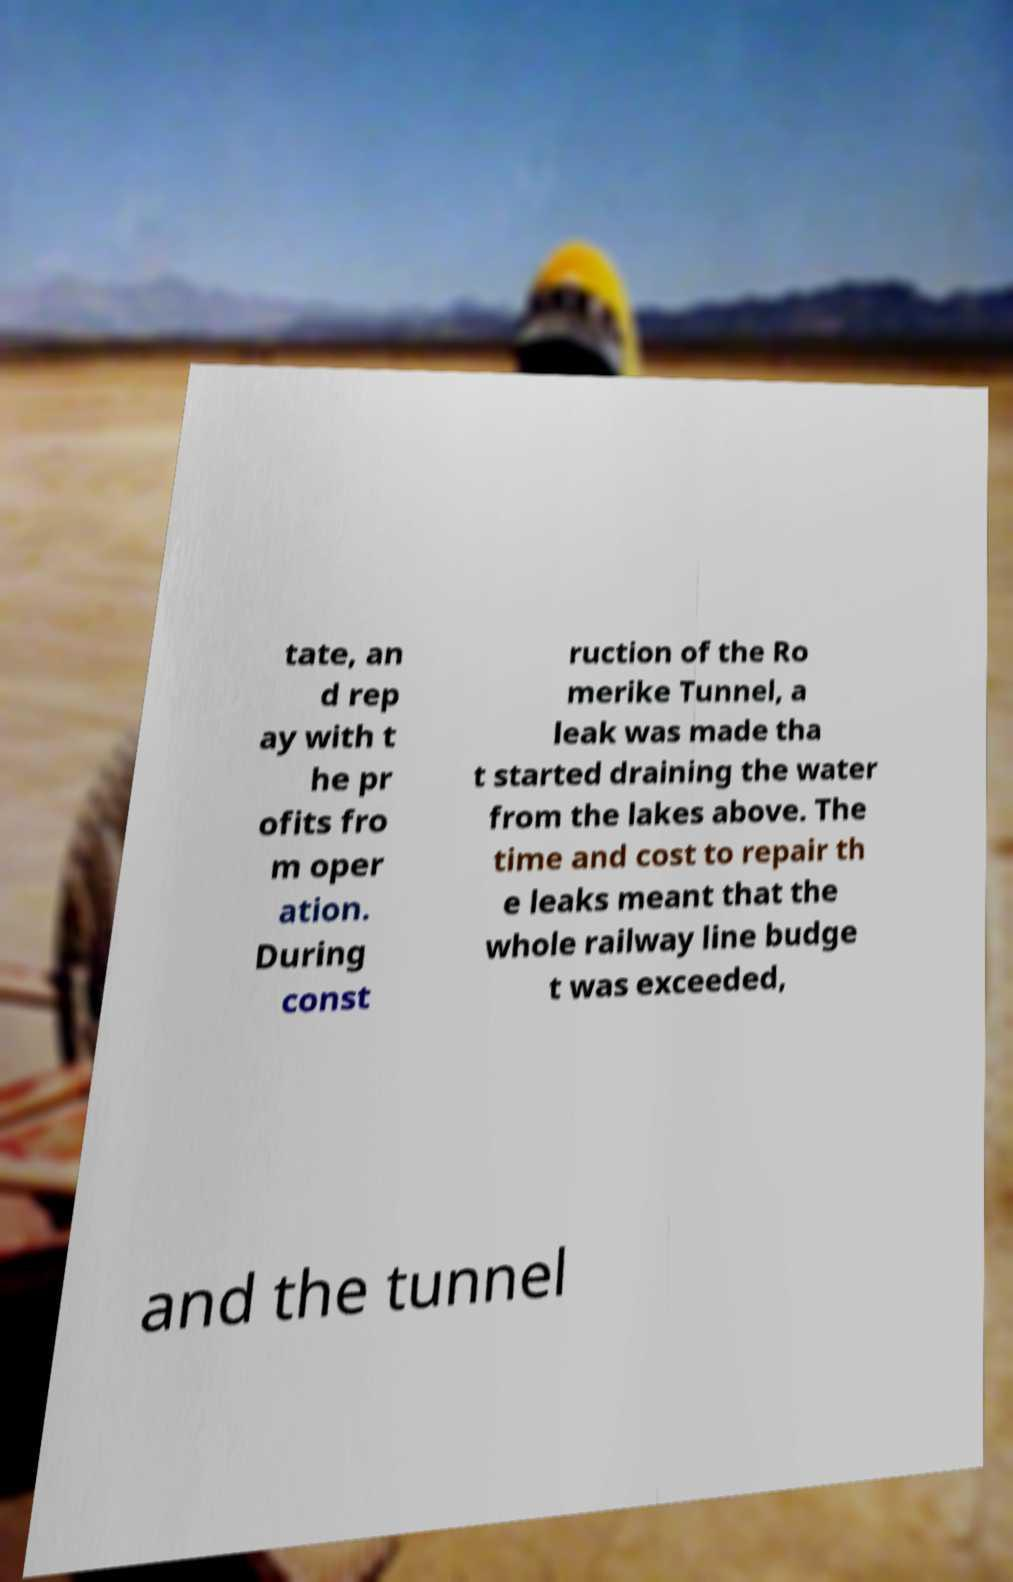What messages or text are displayed in this image? I need them in a readable, typed format. tate, an d rep ay with t he pr ofits fro m oper ation. During const ruction of the Ro merike Tunnel, a leak was made tha t started draining the water from the lakes above. The time and cost to repair th e leaks meant that the whole railway line budge t was exceeded, and the tunnel 